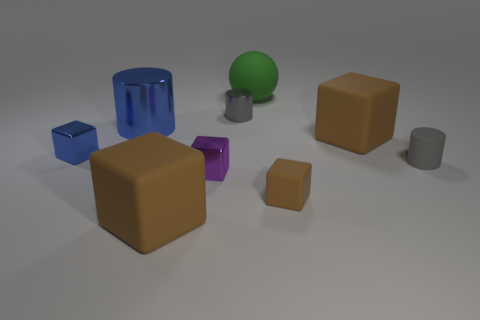Subtract all green balls. How many brown cubes are left? 3 Subtract all blue shiny blocks. How many blocks are left? 4 Subtract all blue cubes. How many cubes are left? 4 Subtract 1 cubes. How many cubes are left? 4 Subtract all gray cubes. Subtract all red cylinders. How many cubes are left? 5 Add 1 big matte things. How many objects exist? 10 Subtract all cylinders. How many objects are left? 6 Subtract 0 blue spheres. How many objects are left? 9 Subtract all tiny rubber cubes. Subtract all blue cylinders. How many objects are left? 7 Add 7 large cubes. How many large cubes are left? 9 